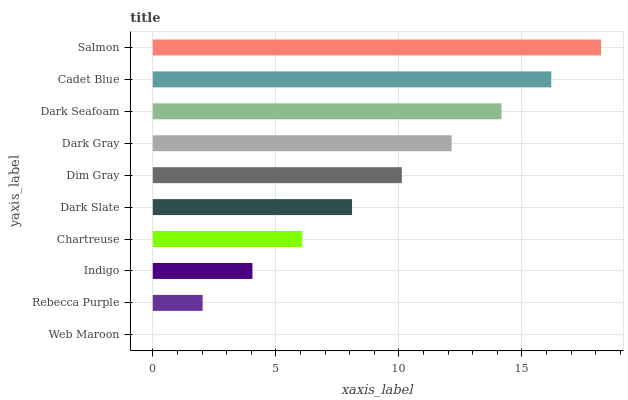Is Web Maroon the minimum?
Answer yes or no. Yes. Is Salmon the maximum?
Answer yes or no. Yes. Is Rebecca Purple the minimum?
Answer yes or no. No. Is Rebecca Purple the maximum?
Answer yes or no. No. Is Rebecca Purple greater than Web Maroon?
Answer yes or no. Yes. Is Web Maroon less than Rebecca Purple?
Answer yes or no. Yes. Is Web Maroon greater than Rebecca Purple?
Answer yes or no. No. Is Rebecca Purple less than Web Maroon?
Answer yes or no. No. Is Dim Gray the high median?
Answer yes or no. Yes. Is Dark Slate the low median?
Answer yes or no. Yes. Is Dark Seafoam the high median?
Answer yes or no. No. Is Dim Gray the low median?
Answer yes or no. No. 